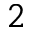Convert formula to latex. <formula><loc_0><loc_0><loc_500><loc_500>_ { 2 }</formula> 